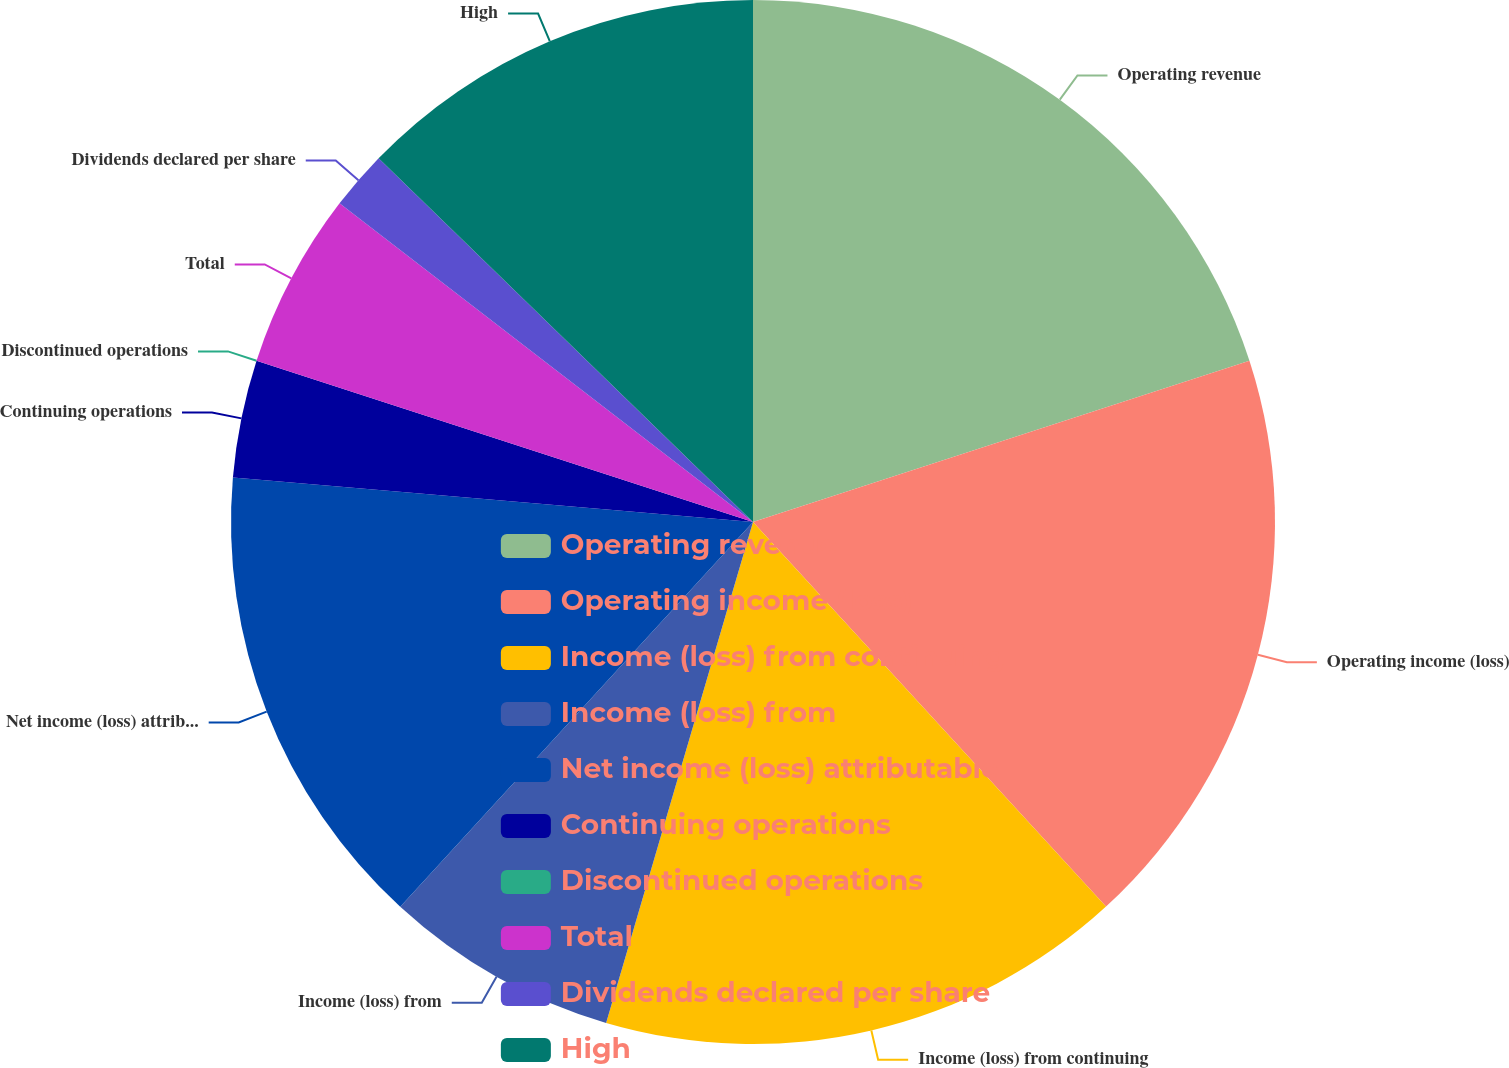<chart> <loc_0><loc_0><loc_500><loc_500><pie_chart><fcel>Operating revenue<fcel>Operating income (loss)<fcel>Income (loss) from continuing<fcel>Income (loss) from<fcel>Net income (loss) attributable<fcel>Continuing operations<fcel>Discontinued operations<fcel>Total<fcel>Dividends declared per share<fcel>High<nl><fcel>20.0%<fcel>18.18%<fcel>16.36%<fcel>7.27%<fcel>14.55%<fcel>3.64%<fcel>0.0%<fcel>5.45%<fcel>1.82%<fcel>12.73%<nl></chart> 